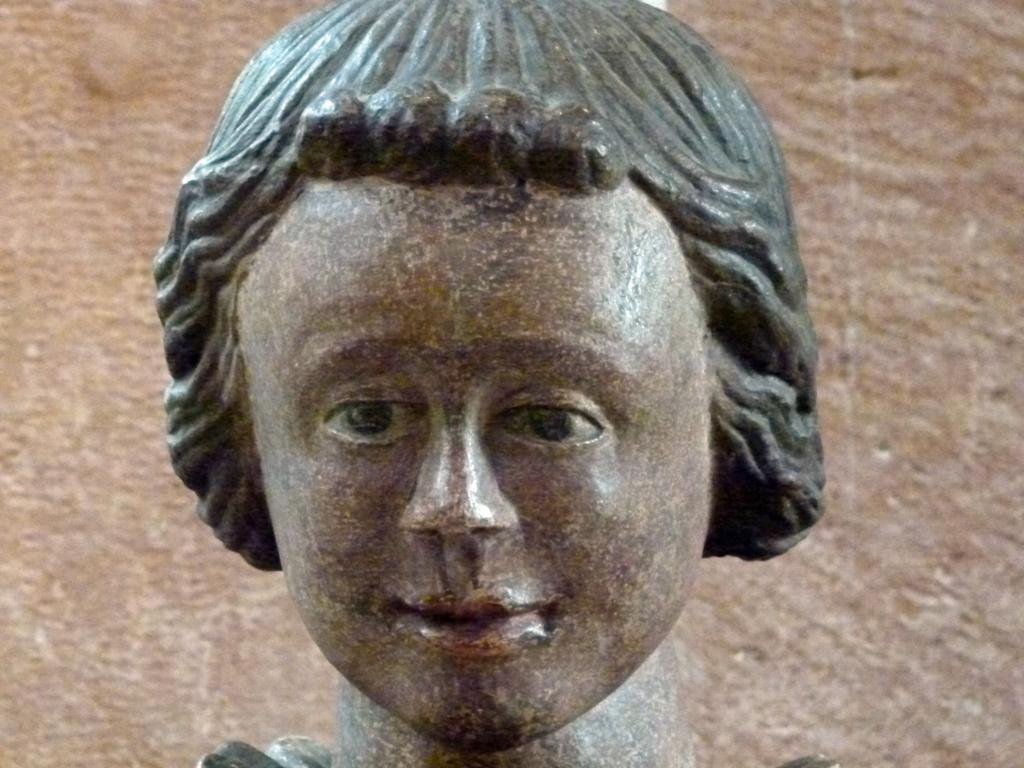What is the main subject of the image? There is a sculpture in the image. Can you describe the sculpture? The sculpture is a human head. What color is the background of the image? The background of the image is in brown color. What decision does the fireman make in the image? There is no fireman or decision present in the image; it features a sculpture of a human head with a brown background. 